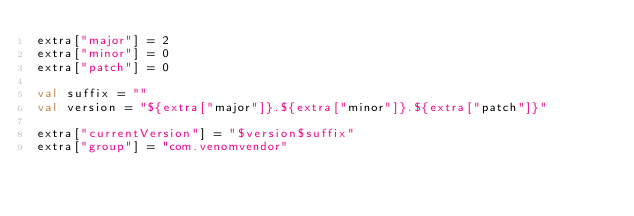Convert code to text. <code><loc_0><loc_0><loc_500><loc_500><_Kotlin_>extra["major"] = 2
extra["minor"] = 0
extra["patch"] = 0

val suffix = ""
val version = "${extra["major"]}.${extra["minor"]}.${extra["patch"]}"

extra["currentVersion"] = "$version$suffix"
extra["group"] = "com.venomvendor"
</code> 